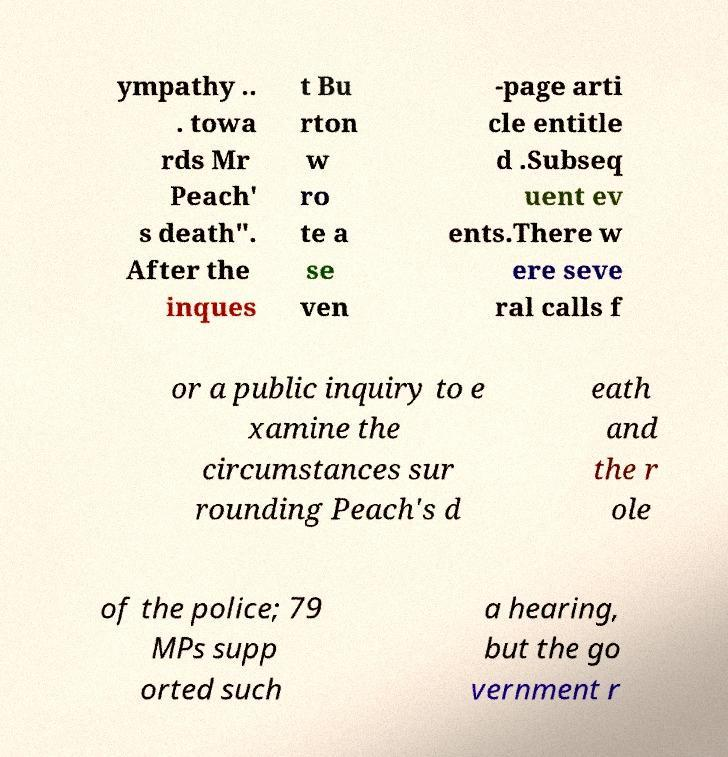Please identify and transcribe the text found in this image. ympathy .. . towa rds Mr Peach' s death". After the inques t Bu rton w ro te a se ven -page arti cle entitle d .Subseq uent ev ents.There w ere seve ral calls f or a public inquiry to e xamine the circumstances sur rounding Peach's d eath and the r ole of the police; 79 MPs supp orted such a hearing, but the go vernment r 